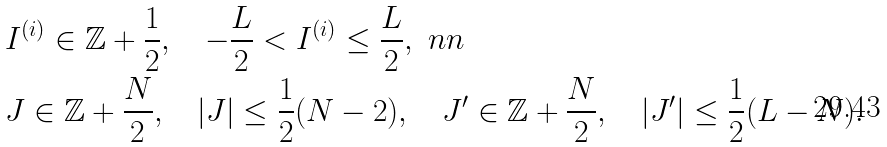Convert formula to latex. <formula><loc_0><loc_0><loc_500><loc_500>& I ^ { ( i ) } \in \mathbb { Z } + \frac { 1 } { 2 } , \quad - \frac { L } { 2 } < I ^ { ( i ) } \leq \frac { L } { 2 } , \ n n \\ & J \in \mathbb { Z } + \frac { N } { 2 } , \quad | J | \leq \frac { 1 } { 2 } ( N - 2 ) , \quad J ^ { \prime } \in \mathbb { Z } + \frac { N } { 2 } , \quad | J ^ { \prime } | \leq \frac { 1 } { 2 } ( L - N ) .</formula> 